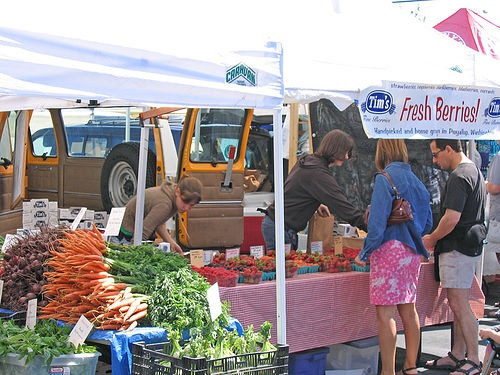Describe the objects in this image and their specific colors. I can see truck in white, gray, black, maroon, and darkgray tones, people in white, brown, blue, and violet tones, people in white, black, darkgray, and gray tones, carrot in white, brown, maroon, and salmon tones, and people in white, gray, and black tones in this image. 